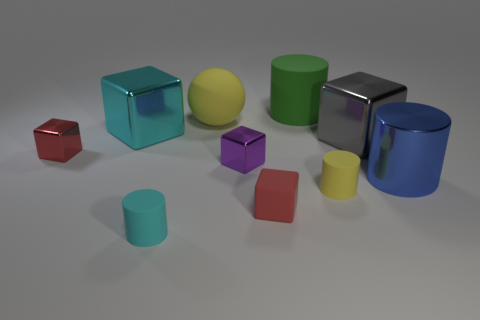Subtract all small purple shiny blocks. How many blocks are left? 4 Subtract all purple cubes. How many cubes are left? 4 Subtract 2 cubes. How many cubes are left? 3 Subtract all blue blocks. Subtract all gray balls. How many blocks are left? 5 Subtract all cylinders. How many objects are left? 6 Subtract all large gray shiny objects. Subtract all tiny cubes. How many objects are left? 6 Add 3 red rubber cubes. How many red rubber cubes are left? 4 Add 7 matte balls. How many matte balls exist? 8 Subtract 0 gray cylinders. How many objects are left? 10 